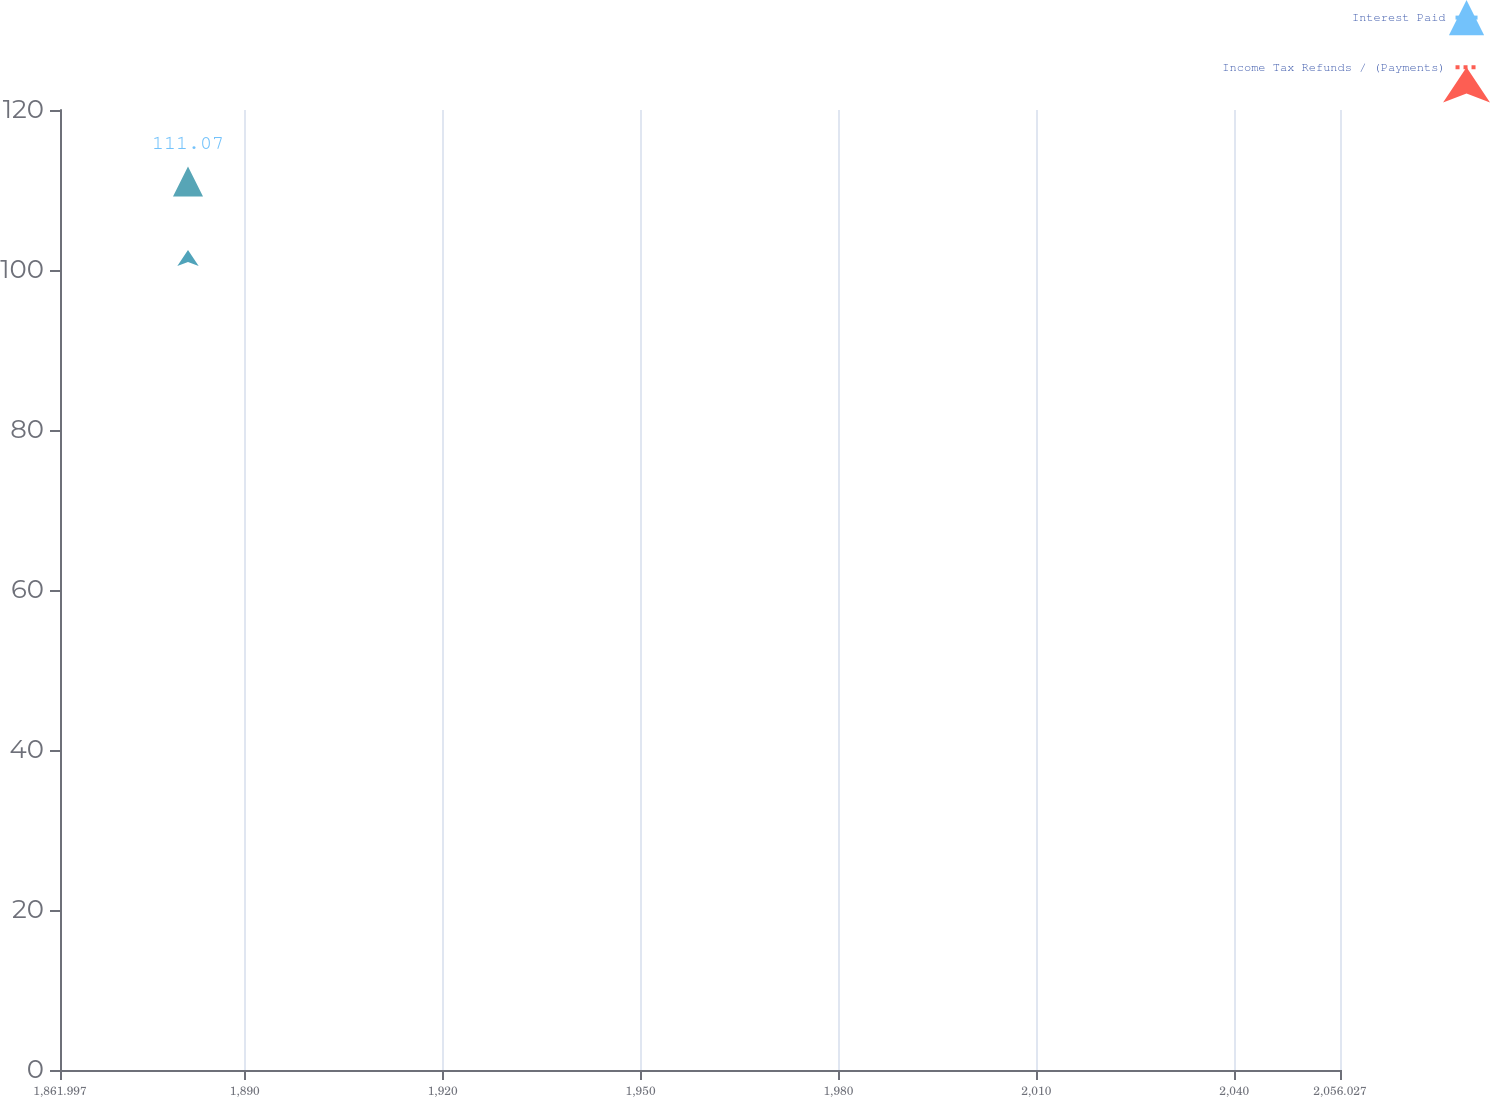Convert chart. <chart><loc_0><loc_0><loc_500><loc_500><line_chart><ecel><fcel>Interest Paid<fcel>Income Tax Refunds / (Payments)<nl><fcel>1881.4<fcel>111.07<fcel>102.5<nl><fcel>2057.76<fcel>237.36<fcel>456.15<nl><fcel>2075.43<fcel>314.27<fcel>155.92<nl></chart> 